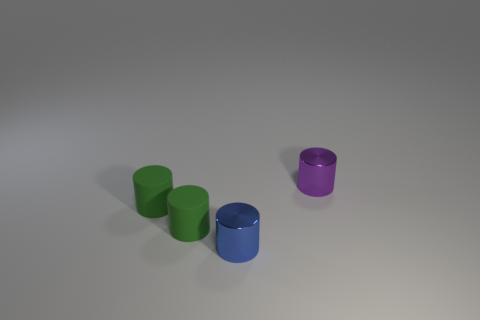Subtract all small blue cylinders. How many cylinders are left? 3 Add 1 green matte objects. How many objects exist? 5 Subtract all blue cylinders. How many cylinders are left? 3 Subtract all yellow spheres. How many green cylinders are left? 2 Subtract all big purple spheres. Subtract all tiny purple metal cylinders. How many objects are left? 3 Add 4 cylinders. How many cylinders are left? 8 Add 3 rubber objects. How many rubber objects exist? 5 Subtract 0 yellow cylinders. How many objects are left? 4 Subtract all green cylinders. Subtract all blue spheres. How many cylinders are left? 2 